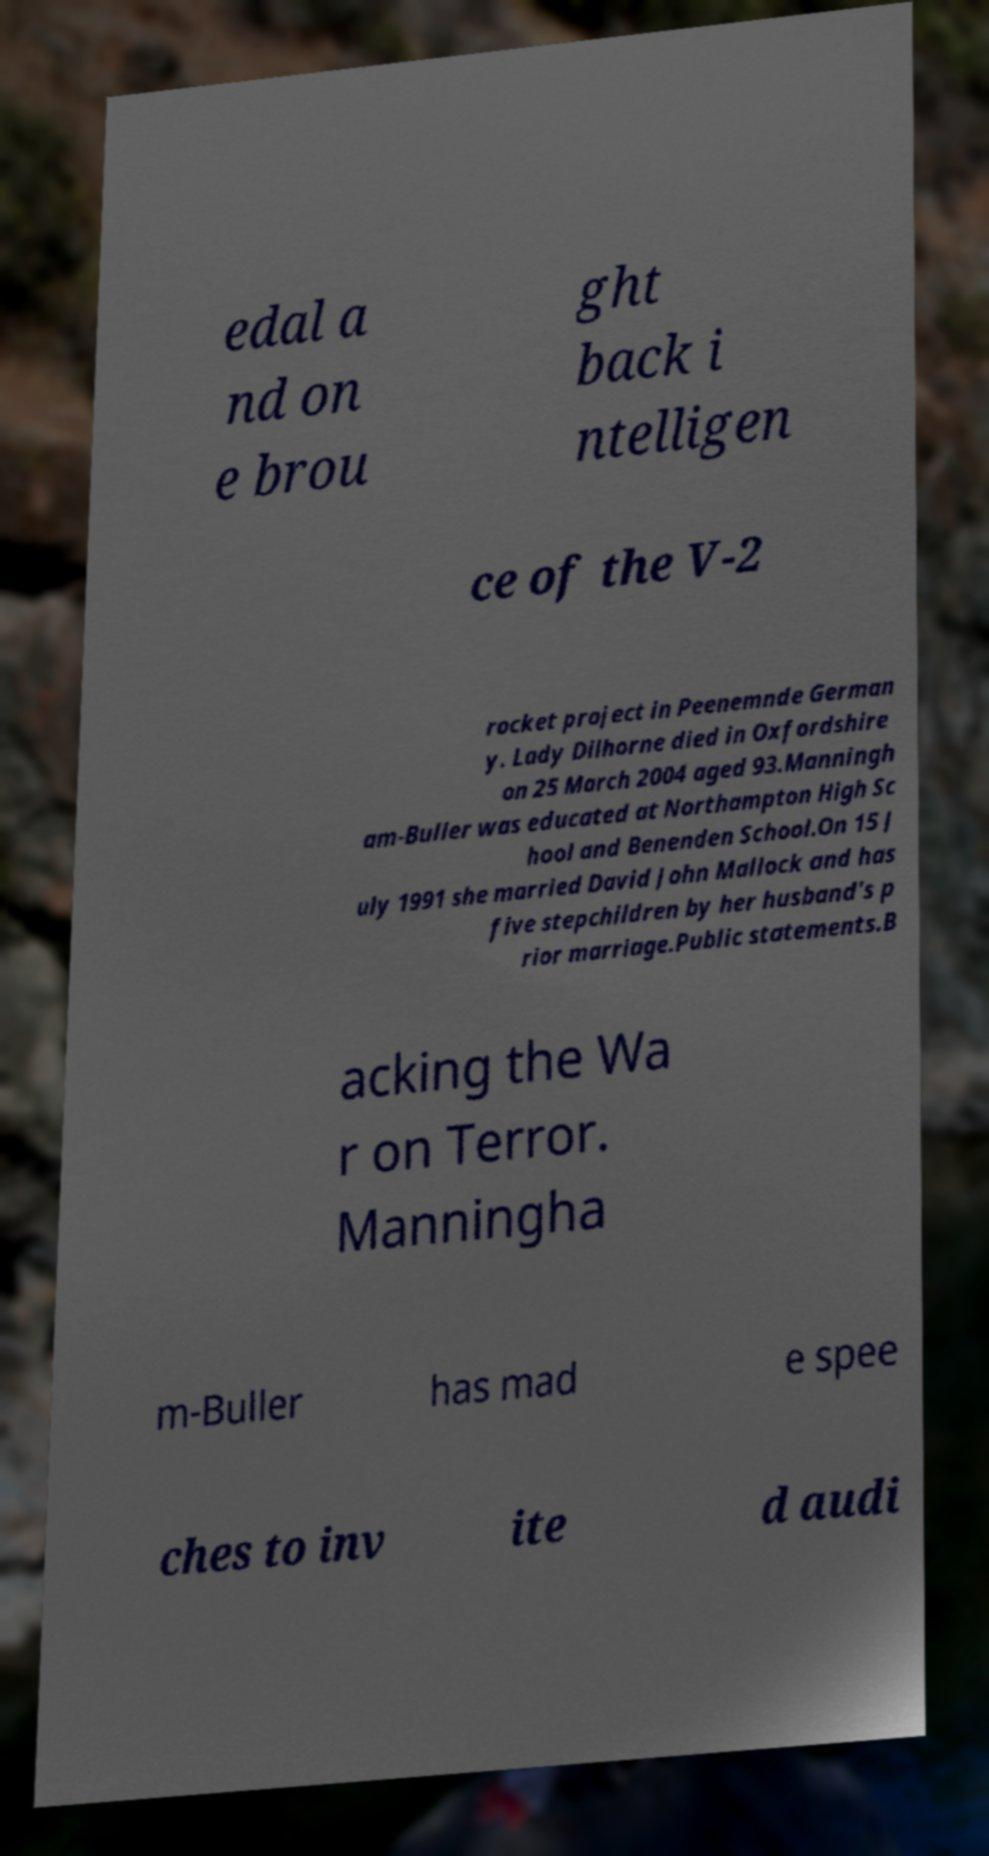Can you accurately transcribe the text from the provided image for me? edal a nd on e brou ght back i ntelligen ce of the V-2 rocket project in Peenemnde German y. Lady Dilhorne died in Oxfordshire on 25 March 2004 aged 93.Manningh am-Buller was educated at Northampton High Sc hool and Benenden School.On 15 J uly 1991 she married David John Mallock and has five stepchildren by her husband's p rior marriage.Public statements.B acking the Wa r on Terror. Manningha m-Buller has mad e spee ches to inv ite d audi 